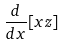Convert formula to latex. <formula><loc_0><loc_0><loc_500><loc_500>\frac { d } { d x } [ x z ]</formula> 